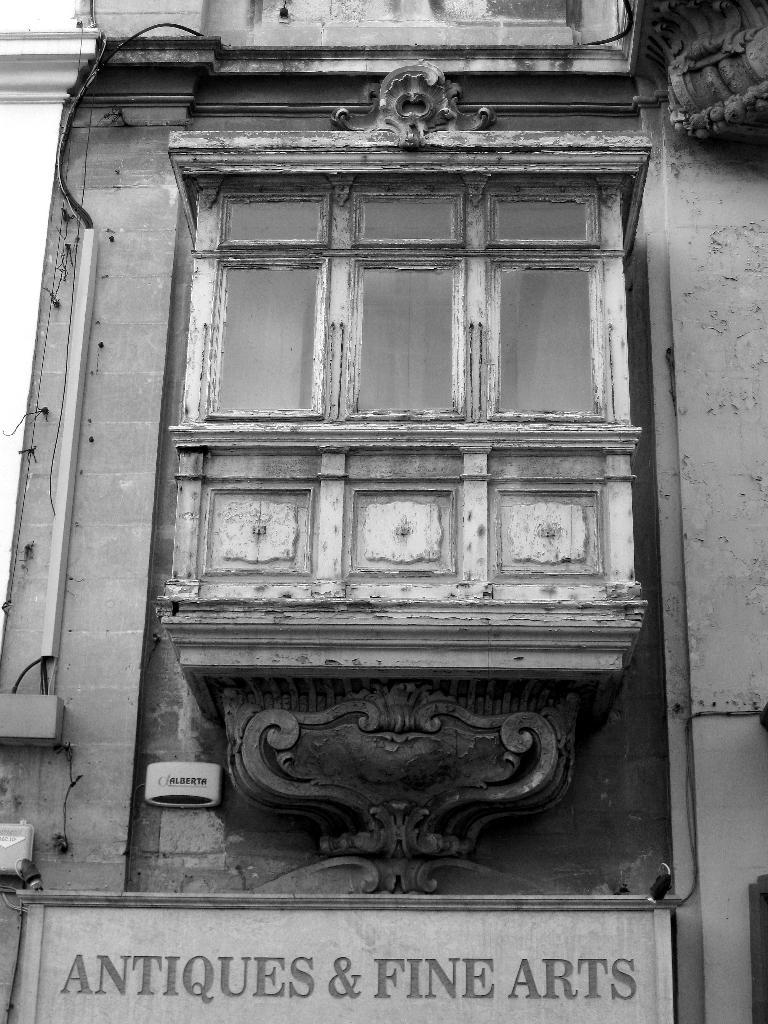What is the color scheme of the image? The image is black and white. What is located at the bottom of the image? There is a board at the bottom of the image with text on it. What object is in the middle of the image? There is a wooden box in the middle of the image. How is the wooden box positioned in the image? The wooden box is attached to the wall. What type of shoes can be seen in the garden in the image? There is no garden or shoes present in the image; it features a black and white image with a board, text, and a wooden box attached to the wall. 